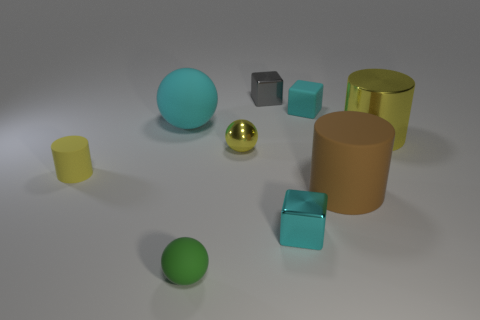There is a cylinder that is the same size as the cyan metallic cube; what color is it?
Ensure brevity in your answer.  Yellow. How many matte objects are tiny blocks or large yellow objects?
Keep it short and to the point. 1. Is the number of yellow shiny objects the same as the number of tiny cyan metal objects?
Offer a very short reply. No. How many cyan blocks are in front of the brown thing and behind the cyan metal block?
Make the answer very short. 0. Is there any other thing that has the same shape as the tiny green rubber object?
Give a very brief answer. Yes. How many other objects are the same size as the gray metal object?
Keep it short and to the point. 5. Do the yellow thing that is behind the yellow shiny sphere and the cube in front of the brown object have the same size?
Your answer should be compact. No. What number of objects are big yellow metallic cubes or rubber things behind the tiny yellow cylinder?
Your response must be concise. 2. What is the size of the yellow object that is to the left of the tiny rubber ball?
Provide a short and direct response. Small. Are there fewer green rubber balls that are behind the large matte cylinder than big brown objects that are in front of the small cyan metal block?
Provide a succinct answer. No. 